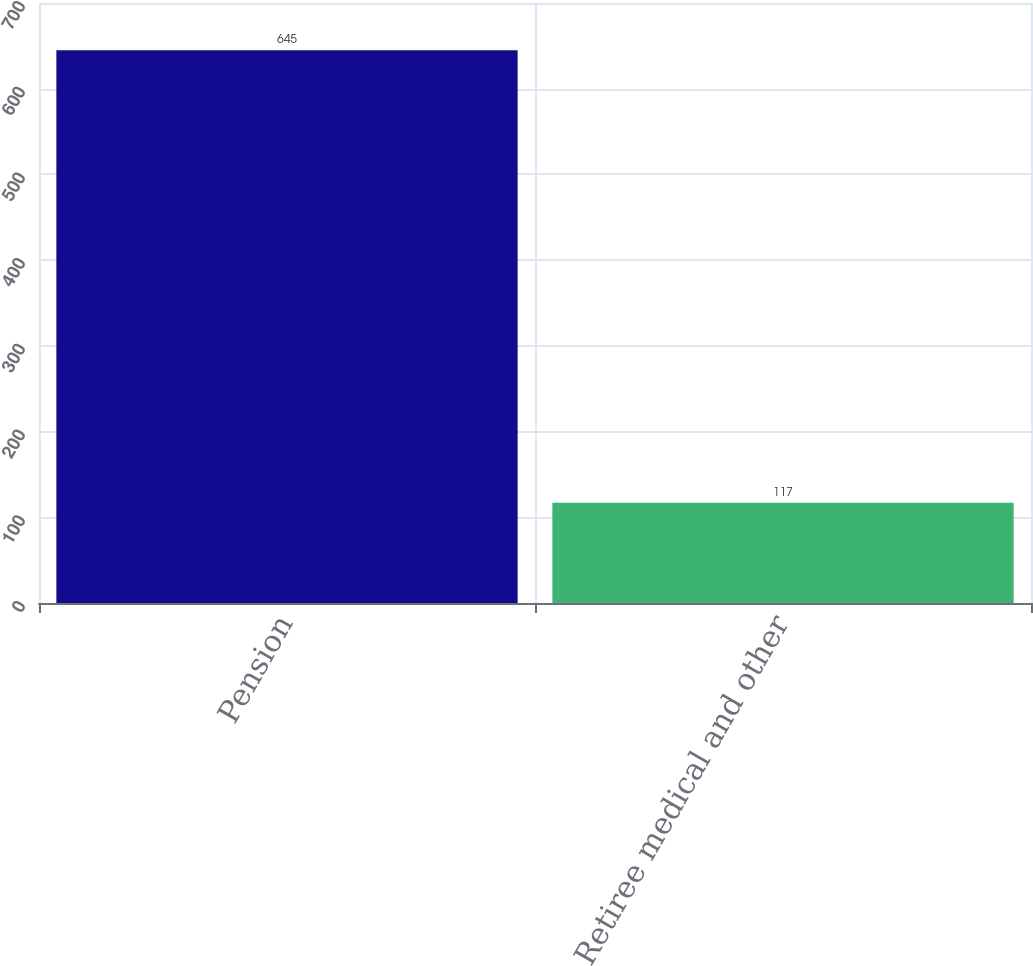<chart> <loc_0><loc_0><loc_500><loc_500><bar_chart><fcel>Pension<fcel>Retiree medical and other<nl><fcel>645<fcel>117<nl></chart> 